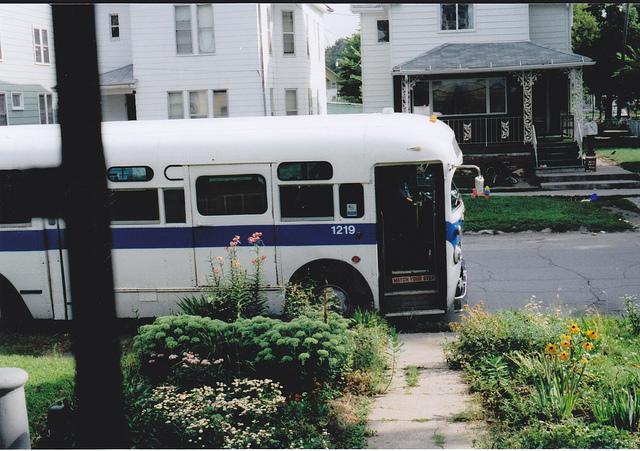How many vehicles are in the shot?
Give a very brief answer. 1. 